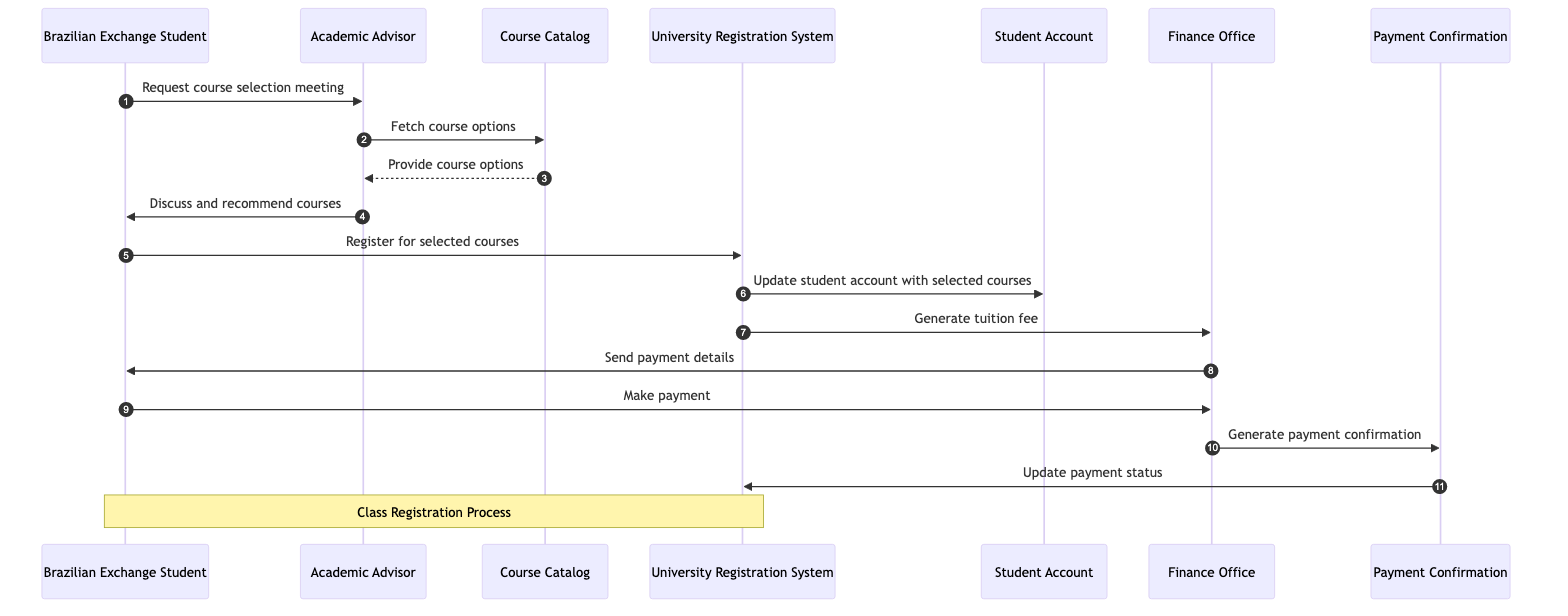What's the first action taken by the Brazilian Exchange Student? The student makes the first move by requesting a meeting with the academic advisor to discuss course selection. This action initiates the class registration process.
Answer: Request course selection meeting How many actors are involved in this diagram? The diagram includes four actors: the Brazilian Exchange Student, Academic Advisor, University Registration System, and Finance Office. Counting these gives a total of four actors involved in the process.
Answer: Four What does the Academic Advisor do after fetching course options? After fetching course options, the Academic Advisor discusses and recommends the courses to the Brazilian Exchange Student, which is a critical step to guide the student towards appropriate course selections.
Answer: Discuss and recommend courses What does the University Registration System do after the student registers for courses? Once the Brazilian Exchange Student registers for the selected courses, the University Registration System updates the student account with the chosen courses, ensuring that the student’s records reflect the new registration.
Answer: Update student account with selected courses What is generated by the Finance Office after the student makes a payment? The Finance Office generates a payment confirmation, which is essential to verify that the payment has been received and acknowledged. This confirmation is a crucial element in the process to ensure that the student's registration status is valid.
Answer: Generate payment confirmation Explain the flow of information from the Course Catalog to the Academic Advisor in this diagram. The Academic Advisor first requests course options from the Course Catalog. In response, the Course Catalog provides the available course options back to the advisor, allowing them to evaluate and discuss these options with the Brazilian Exchange Student later. This exchange is essential for the advisor to develop informed recommendations based on available courses.
Answer: Provide course options What happens after the Finance Office sends payment details to the Brazilian Exchange Student? After sending the payment details, the Brazilian Exchange Student proceeds to make the payment to the Finance Office. This action directly follows the exchange of payment information, showcasing the progression towards completing the registration process through financial settlement.
Answer: Make payment Which system updates the payment status? The Payment Confirmation updates the payment status in the University Registration System after confirming that the tuition payment has been received. This step is crucial to reflect the student’s financial standing related to their course registration.
Answer: University Registration System How many steps are involved in the class registration process as depicted in the sequence diagram? The diagram includes a total of eleven distinct steps, which encompass the complete flow of actions from the initial meeting request to the payment confirmation, detailing all interactions among actors and systems involved in the process.
Answer: Eleven steps 